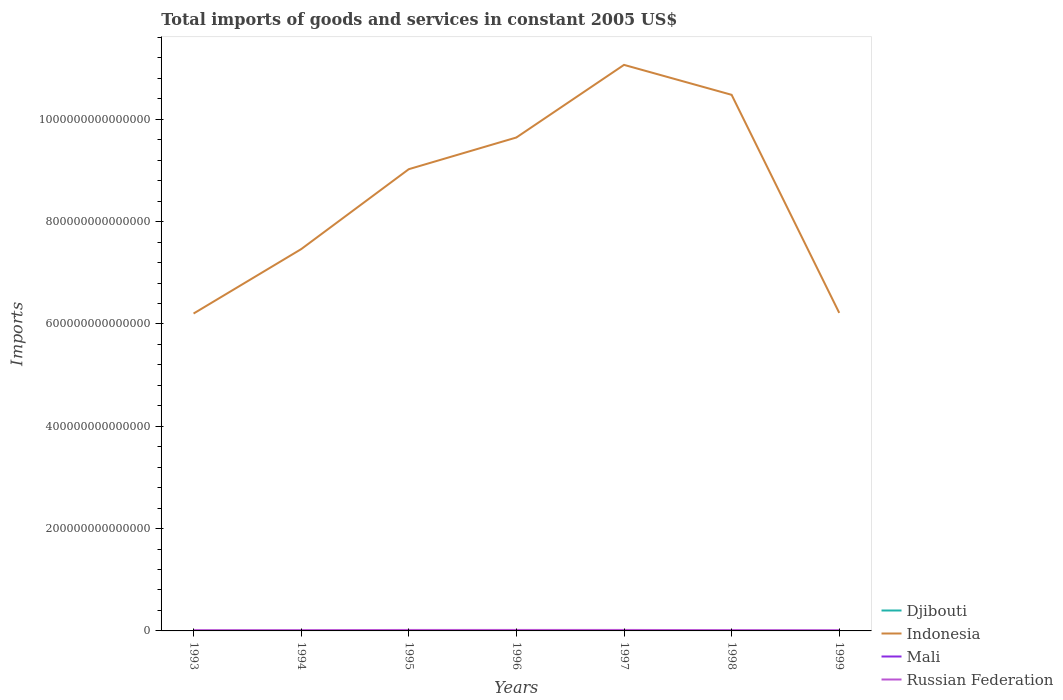How many different coloured lines are there?
Ensure brevity in your answer.  4. Does the line corresponding to Russian Federation intersect with the line corresponding to Djibouti?
Provide a succinct answer. No. Across all years, what is the maximum total imports of goods and services in Indonesia?
Ensure brevity in your answer.  6.20e+14. In which year was the total imports of goods and services in Djibouti maximum?
Offer a very short reply. 1999. What is the total total imports of goods and services in Djibouti in the graph?
Make the answer very short. 1.29e+1. What is the difference between the highest and the second highest total imports of goods and services in Djibouti?
Your answer should be compact. 1.38e+1. What is the difference between the highest and the lowest total imports of goods and services in Mali?
Provide a short and direct response. 3. Is the total imports of goods and services in Mali strictly greater than the total imports of goods and services in Djibouti over the years?
Offer a very short reply. No. How many lines are there?
Provide a succinct answer. 4. How many years are there in the graph?
Offer a terse response. 7. What is the difference between two consecutive major ticks on the Y-axis?
Provide a short and direct response. 2.00e+14. Are the values on the major ticks of Y-axis written in scientific E-notation?
Ensure brevity in your answer.  No. Does the graph contain any zero values?
Give a very brief answer. No. How many legend labels are there?
Provide a succinct answer. 4. How are the legend labels stacked?
Keep it short and to the point. Vertical. What is the title of the graph?
Make the answer very short. Total imports of goods and services in constant 2005 US$. What is the label or title of the Y-axis?
Offer a very short reply. Imports. What is the Imports of Djibouti in 1993?
Provide a short and direct response. 4.61e+1. What is the Imports of Indonesia in 1993?
Your answer should be very brief. 6.20e+14. What is the Imports in Mali in 1993?
Your answer should be compact. 2.15e+11. What is the Imports in Russian Federation in 1993?
Provide a short and direct response. 1.51e+12. What is the Imports in Djibouti in 1994?
Provide a short and direct response. 3.99e+1. What is the Imports of Indonesia in 1994?
Offer a very short reply. 7.46e+14. What is the Imports in Mali in 1994?
Make the answer very short. 1.93e+11. What is the Imports in Russian Federation in 1994?
Your response must be concise. 1.57e+12. What is the Imports in Djibouti in 1995?
Make the answer very short. 3.52e+1. What is the Imports in Indonesia in 1995?
Offer a terse response. 9.03e+14. What is the Imports of Mali in 1995?
Keep it short and to the point. 2.36e+11. What is the Imports in Russian Federation in 1995?
Ensure brevity in your answer.  1.90e+12. What is the Imports of Djibouti in 1996?
Offer a terse response. 3.32e+1. What is the Imports in Indonesia in 1996?
Your response must be concise. 9.65e+14. What is the Imports of Mali in 1996?
Offer a terse response. 2.27e+11. What is the Imports in Russian Federation in 1996?
Give a very brief answer. 1.93e+12. What is the Imports of Djibouti in 1997?
Keep it short and to the point. 3.29e+1. What is the Imports in Indonesia in 1997?
Ensure brevity in your answer.  1.11e+15. What is the Imports of Mali in 1997?
Provide a succinct answer. 2.42e+11. What is the Imports of Russian Federation in 1997?
Your response must be concise. 1.93e+12. What is the Imports in Djibouti in 1998?
Ensure brevity in your answer.  3.50e+1. What is the Imports of Indonesia in 1998?
Make the answer very short. 1.05e+15. What is the Imports of Mali in 1998?
Your answer should be very brief. 2.80e+11. What is the Imports of Russian Federation in 1998?
Your answer should be compact. 1.60e+12. What is the Imports in Djibouti in 1999?
Provide a succinct answer. 3.23e+1. What is the Imports of Indonesia in 1999?
Ensure brevity in your answer.  6.22e+14. What is the Imports of Mali in 1999?
Offer a terse response. 2.89e+11. What is the Imports in Russian Federation in 1999?
Make the answer very short. 1.33e+12. Across all years, what is the maximum Imports of Djibouti?
Ensure brevity in your answer.  4.61e+1. Across all years, what is the maximum Imports in Indonesia?
Keep it short and to the point. 1.11e+15. Across all years, what is the maximum Imports of Mali?
Offer a very short reply. 2.89e+11. Across all years, what is the maximum Imports in Russian Federation?
Offer a very short reply. 1.93e+12. Across all years, what is the minimum Imports of Djibouti?
Ensure brevity in your answer.  3.23e+1. Across all years, what is the minimum Imports in Indonesia?
Provide a short and direct response. 6.20e+14. Across all years, what is the minimum Imports of Mali?
Make the answer very short. 1.93e+11. Across all years, what is the minimum Imports in Russian Federation?
Make the answer very short. 1.33e+12. What is the total Imports in Djibouti in the graph?
Make the answer very short. 2.55e+11. What is the total Imports of Indonesia in the graph?
Provide a succinct answer. 6.01e+15. What is the total Imports in Mali in the graph?
Offer a terse response. 1.68e+12. What is the total Imports of Russian Federation in the graph?
Your answer should be very brief. 1.18e+13. What is the difference between the Imports in Djibouti in 1993 and that in 1994?
Offer a very short reply. 6.25e+09. What is the difference between the Imports of Indonesia in 1993 and that in 1994?
Offer a terse response. -1.26e+14. What is the difference between the Imports in Mali in 1993 and that in 1994?
Offer a very short reply. 2.21e+1. What is the difference between the Imports in Russian Federation in 1993 and that in 1994?
Offer a terse response. -6.35e+1. What is the difference between the Imports in Djibouti in 1993 and that in 1995?
Make the answer very short. 1.09e+1. What is the difference between the Imports of Indonesia in 1993 and that in 1995?
Offer a terse response. -2.82e+14. What is the difference between the Imports in Mali in 1993 and that in 1995?
Offer a very short reply. -2.08e+1. What is the difference between the Imports of Russian Federation in 1993 and that in 1995?
Keep it short and to the point. -3.96e+11. What is the difference between the Imports of Djibouti in 1993 and that in 1996?
Provide a short and direct response. 1.29e+1. What is the difference between the Imports of Indonesia in 1993 and that in 1996?
Your answer should be compact. -3.44e+14. What is the difference between the Imports of Mali in 1993 and that in 1996?
Your response must be concise. -1.21e+1. What is the difference between the Imports in Russian Federation in 1993 and that in 1996?
Keep it short and to the point. -4.20e+11. What is the difference between the Imports in Djibouti in 1993 and that in 1997?
Offer a very short reply. 1.32e+1. What is the difference between the Imports of Indonesia in 1993 and that in 1997?
Provide a short and direct response. -4.86e+14. What is the difference between the Imports of Mali in 1993 and that in 1997?
Make the answer very short. -2.70e+1. What is the difference between the Imports in Russian Federation in 1993 and that in 1997?
Your answer should be very brief. -4.28e+11. What is the difference between the Imports of Djibouti in 1993 and that in 1998?
Your response must be concise. 1.12e+1. What is the difference between the Imports in Indonesia in 1993 and that in 1998?
Your answer should be very brief. -4.28e+14. What is the difference between the Imports in Mali in 1993 and that in 1998?
Provide a succinct answer. -6.44e+1. What is the difference between the Imports of Russian Federation in 1993 and that in 1998?
Keep it short and to the point. -9.15e+1. What is the difference between the Imports in Djibouti in 1993 and that in 1999?
Give a very brief answer. 1.38e+1. What is the difference between the Imports of Indonesia in 1993 and that in 1999?
Ensure brevity in your answer.  -1.29e+12. What is the difference between the Imports in Mali in 1993 and that in 1999?
Your answer should be compact. -7.41e+1. What is the difference between the Imports of Russian Federation in 1993 and that in 1999?
Offer a very short reply. 1.80e+11. What is the difference between the Imports of Djibouti in 1994 and that in 1995?
Provide a succinct answer. 4.70e+09. What is the difference between the Imports of Indonesia in 1994 and that in 1995?
Provide a succinct answer. -1.56e+14. What is the difference between the Imports of Mali in 1994 and that in 1995?
Your answer should be compact. -4.29e+1. What is the difference between the Imports in Russian Federation in 1994 and that in 1995?
Provide a short and direct response. -3.32e+11. What is the difference between the Imports in Djibouti in 1994 and that in 1996?
Offer a terse response. 6.69e+09. What is the difference between the Imports of Indonesia in 1994 and that in 1996?
Provide a succinct answer. -2.18e+14. What is the difference between the Imports in Mali in 1994 and that in 1996?
Provide a short and direct response. -3.41e+1. What is the difference between the Imports in Russian Federation in 1994 and that in 1996?
Give a very brief answer. -3.57e+11. What is the difference between the Imports of Djibouti in 1994 and that in 1997?
Make the answer very short. 6.97e+09. What is the difference between the Imports in Indonesia in 1994 and that in 1997?
Provide a succinct answer. -3.60e+14. What is the difference between the Imports in Mali in 1994 and that in 1997?
Make the answer very short. -4.90e+1. What is the difference between the Imports in Russian Federation in 1994 and that in 1997?
Offer a very short reply. -3.65e+11. What is the difference between the Imports in Djibouti in 1994 and that in 1998?
Your answer should be very brief. 4.90e+09. What is the difference between the Imports of Indonesia in 1994 and that in 1998?
Your answer should be very brief. -3.02e+14. What is the difference between the Imports of Mali in 1994 and that in 1998?
Your answer should be very brief. -8.65e+1. What is the difference between the Imports in Russian Federation in 1994 and that in 1998?
Provide a short and direct response. -2.80e+1. What is the difference between the Imports in Djibouti in 1994 and that in 1999?
Make the answer very short. 7.54e+09. What is the difference between the Imports of Indonesia in 1994 and that in 1999?
Keep it short and to the point. 1.25e+14. What is the difference between the Imports of Mali in 1994 and that in 1999?
Ensure brevity in your answer.  -9.62e+1. What is the difference between the Imports in Russian Federation in 1994 and that in 1999?
Your answer should be very brief. 2.44e+11. What is the difference between the Imports of Djibouti in 1995 and that in 1996?
Ensure brevity in your answer.  2.00e+09. What is the difference between the Imports in Indonesia in 1995 and that in 1996?
Your response must be concise. -6.20e+13. What is the difference between the Imports of Mali in 1995 and that in 1996?
Offer a terse response. 8.77e+09. What is the difference between the Imports in Russian Federation in 1995 and that in 1996?
Make the answer very short. -2.47e+1. What is the difference between the Imports of Djibouti in 1995 and that in 1997?
Offer a very short reply. 2.28e+09. What is the difference between the Imports of Indonesia in 1995 and that in 1997?
Your answer should be compact. -2.04e+14. What is the difference between the Imports of Mali in 1995 and that in 1997?
Ensure brevity in your answer.  -6.14e+09. What is the difference between the Imports of Russian Federation in 1995 and that in 1997?
Offer a terse response. -3.24e+1. What is the difference between the Imports in Djibouti in 1995 and that in 1998?
Make the answer very short. 2.03e+08. What is the difference between the Imports of Indonesia in 1995 and that in 1998?
Offer a terse response. -1.45e+14. What is the difference between the Imports of Mali in 1995 and that in 1998?
Make the answer very short. -4.36e+1. What is the difference between the Imports of Russian Federation in 1995 and that in 1998?
Offer a terse response. 3.04e+11. What is the difference between the Imports in Djibouti in 1995 and that in 1999?
Make the answer very short. 2.85e+09. What is the difference between the Imports of Indonesia in 1995 and that in 1999?
Ensure brevity in your answer.  2.81e+14. What is the difference between the Imports in Mali in 1995 and that in 1999?
Provide a succinct answer. -5.32e+1. What is the difference between the Imports of Russian Federation in 1995 and that in 1999?
Keep it short and to the point. 5.76e+11. What is the difference between the Imports in Djibouti in 1996 and that in 1997?
Give a very brief answer. 2.83e+08. What is the difference between the Imports in Indonesia in 1996 and that in 1997?
Give a very brief answer. -1.42e+14. What is the difference between the Imports of Mali in 1996 and that in 1997?
Give a very brief answer. -1.49e+1. What is the difference between the Imports of Russian Federation in 1996 and that in 1997?
Make the answer very short. -7.71e+09. What is the difference between the Imports of Djibouti in 1996 and that in 1998?
Your answer should be very brief. -1.79e+09. What is the difference between the Imports of Indonesia in 1996 and that in 1998?
Give a very brief answer. -8.34e+13. What is the difference between the Imports of Mali in 1996 and that in 1998?
Keep it short and to the point. -5.24e+1. What is the difference between the Imports of Russian Federation in 1996 and that in 1998?
Make the answer very short. 3.29e+11. What is the difference between the Imports in Djibouti in 1996 and that in 1999?
Provide a succinct answer. 8.53e+08. What is the difference between the Imports in Indonesia in 1996 and that in 1999?
Provide a short and direct response. 3.43e+14. What is the difference between the Imports of Mali in 1996 and that in 1999?
Give a very brief answer. -6.20e+1. What is the difference between the Imports of Russian Federation in 1996 and that in 1999?
Your answer should be compact. 6.00e+11. What is the difference between the Imports in Djibouti in 1997 and that in 1998?
Offer a terse response. -2.08e+09. What is the difference between the Imports in Indonesia in 1997 and that in 1998?
Your answer should be very brief. 5.85e+13. What is the difference between the Imports of Mali in 1997 and that in 1998?
Provide a short and direct response. -3.74e+1. What is the difference between the Imports of Russian Federation in 1997 and that in 1998?
Provide a succinct answer. 3.37e+11. What is the difference between the Imports of Djibouti in 1997 and that in 1999?
Offer a very short reply. 5.70e+08. What is the difference between the Imports in Indonesia in 1997 and that in 1999?
Your response must be concise. 4.85e+14. What is the difference between the Imports in Mali in 1997 and that in 1999?
Offer a terse response. -4.71e+1. What is the difference between the Imports in Russian Federation in 1997 and that in 1999?
Offer a very short reply. 6.08e+11. What is the difference between the Imports in Djibouti in 1998 and that in 1999?
Your response must be concise. 2.65e+09. What is the difference between the Imports in Indonesia in 1998 and that in 1999?
Your answer should be very brief. 4.26e+14. What is the difference between the Imports of Mali in 1998 and that in 1999?
Give a very brief answer. -9.66e+09. What is the difference between the Imports of Russian Federation in 1998 and that in 1999?
Offer a terse response. 2.72e+11. What is the difference between the Imports in Djibouti in 1993 and the Imports in Indonesia in 1994?
Your answer should be very brief. -7.46e+14. What is the difference between the Imports in Djibouti in 1993 and the Imports in Mali in 1994?
Offer a terse response. -1.47e+11. What is the difference between the Imports of Djibouti in 1993 and the Imports of Russian Federation in 1994?
Offer a terse response. -1.52e+12. What is the difference between the Imports in Indonesia in 1993 and the Imports in Mali in 1994?
Keep it short and to the point. 6.20e+14. What is the difference between the Imports in Indonesia in 1993 and the Imports in Russian Federation in 1994?
Your response must be concise. 6.19e+14. What is the difference between the Imports of Mali in 1993 and the Imports of Russian Federation in 1994?
Your answer should be compact. -1.35e+12. What is the difference between the Imports in Djibouti in 1993 and the Imports in Indonesia in 1995?
Provide a succinct answer. -9.03e+14. What is the difference between the Imports of Djibouti in 1993 and the Imports of Mali in 1995?
Offer a terse response. -1.90e+11. What is the difference between the Imports in Djibouti in 1993 and the Imports in Russian Federation in 1995?
Give a very brief answer. -1.86e+12. What is the difference between the Imports of Indonesia in 1993 and the Imports of Mali in 1995?
Offer a terse response. 6.20e+14. What is the difference between the Imports of Indonesia in 1993 and the Imports of Russian Federation in 1995?
Give a very brief answer. 6.19e+14. What is the difference between the Imports in Mali in 1993 and the Imports in Russian Federation in 1995?
Provide a short and direct response. -1.69e+12. What is the difference between the Imports in Djibouti in 1993 and the Imports in Indonesia in 1996?
Your response must be concise. -9.65e+14. What is the difference between the Imports in Djibouti in 1993 and the Imports in Mali in 1996?
Offer a terse response. -1.81e+11. What is the difference between the Imports of Djibouti in 1993 and the Imports of Russian Federation in 1996?
Offer a very short reply. -1.88e+12. What is the difference between the Imports of Indonesia in 1993 and the Imports of Mali in 1996?
Make the answer very short. 6.20e+14. What is the difference between the Imports of Indonesia in 1993 and the Imports of Russian Federation in 1996?
Keep it short and to the point. 6.18e+14. What is the difference between the Imports of Mali in 1993 and the Imports of Russian Federation in 1996?
Give a very brief answer. -1.71e+12. What is the difference between the Imports of Djibouti in 1993 and the Imports of Indonesia in 1997?
Your answer should be compact. -1.11e+15. What is the difference between the Imports in Djibouti in 1993 and the Imports in Mali in 1997?
Ensure brevity in your answer.  -1.96e+11. What is the difference between the Imports in Djibouti in 1993 and the Imports in Russian Federation in 1997?
Provide a succinct answer. -1.89e+12. What is the difference between the Imports in Indonesia in 1993 and the Imports in Mali in 1997?
Keep it short and to the point. 6.20e+14. What is the difference between the Imports of Indonesia in 1993 and the Imports of Russian Federation in 1997?
Your answer should be very brief. 6.18e+14. What is the difference between the Imports in Mali in 1993 and the Imports in Russian Federation in 1997?
Provide a short and direct response. -1.72e+12. What is the difference between the Imports in Djibouti in 1993 and the Imports in Indonesia in 1998?
Offer a terse response. -1.05e+15. What is the difference between the Imports in Djibouti in 1993 and the Imports in Mali in 1998?
Keep it short and to the point. -2.34e+11. What is the difference between the Imports in Djibouti in 1993 and the Imports in Russian Federation in 1998?
Your answer should be compact. -1.55e+12. What is the difference between the Imports in Indonesia in 1993 and the Imports in Mali in 1998?
Make the answer very short. 6.20e+14. What is the difference between the Imports in Indonesia in 1993 and the Imports in Russian Federation in 1998?
Ensure brevity in your answer.  6.19e+14. What is the difference between the Imports of Mali in 1993 and the Imports of Russian Federation in 1998?
Provide a short and direct response. -1.38e+12. What is the difference between the Imports of Djibouti in 1993 and the Imports of Indonesia in 1999?
Provide a succinct answer. -6.22e+14. What is the difference between the Imports in Djibouti in 1993 and the Imports in Mali in 1999?
Provide a short and direct response. -2.43e+11. What is the difference between the Imports in Djibouti in 1993 and the Imports in Russian Federation in 1999?
Give a very brief answer. -1.28e+12. What is the difference between the Imports in Indonesia in 1993 and the Imports in Mali in 1999?
Your answer should be compact. 6.20e+14. What is the difference between the Imports of Indonesia in 1993 and the Imports of Russian Federation in 1999?
Provide a short and direct response. 6.19e+14. What is the difference between the Imports in Mali in 1993 and the Imports in Russian Federation in 1999?
Your answer should be compact. -1.11e+12. What is the difference between the Imports of Djibouti in 1994 and the Imports of Indonesia in 1995?
Give a very brief answer. -9.03e+14. What is the difference between the Imports in Djibouti in 1994 and the Imports in Mali in 1995?
Your answer should be compact. -1.96e+11. What is the difference between the Imports in Djibouti in 1994 and the Imports in Russian Federation in 1995?
Provide a short and direct response. -1.86e+12. What is the difference between the Imports of Indonesia in 1994 and the Imports of Mali in 1995?
Provide a short and direct response. 7.46e+14. What is the difference between the Imports in Indonesia in 1994 and the Imports in Russian Federation in 1995?
Offer a terse response. 7.44e+14. What is the difference between the Imports in Mali in 1994 and the Imports in Russian Federation in 1995?
Provide a succinct answer. -1.71e+12. What is the difference between the Imports of Djibouti in 1994 and the Imports of Indonesia in 1996?
Make the answer very short. -9.65e+14. What is the difference between the Imports in Djibouti in 1994 and the Imports in Mali in 1996?
Your answer should be compact. -1.88e+11. What is the difference between the Imports of Djibouti in 1994 and the Imports of Russian Federation in 1996?
Your response must be concise. -1.89e+12. What is the difference between the Imports of Indonesia in 1994 and the Imports of Mali in 1996?
Provide a succinct answer. 7.46e+14. What is the difference between the Imports of Indonesia in 1994 and the Imports of Russian Federation in 1996?
Offer a very short reply. 7.44e+14. What is the difference between the Imports in Mali in 1994 and the Imports in Russian Federation in 1996?
Provide a short and direct response. -1.73e+12. What is the difference between the Imports of Djibouti in 1994 and the Imports of Indonesia in 1997?
Your answer should be very brief. -1.11e+15. What is the difference between the Imports in Djibouti in 1994 and the Imports in Mali in 1997?
Your response must be concise. -2.02e+11. What is the difference between the Imports of Djibouti in 1994 and the Imports of Russian Federation in 1997?
Ensure brevity in your answer.  -1.89e+12. What is the difference between the Imports in Indonesia in 1994 and the Imports in Mali in 1997?
Ensure brevity in your answer.  7.46e+14. What is the difference between the Imports in Indonesia in 1994 and the Imports in Russian Federation in 1997?
Offer a very short reply. 7.44e+14. What is the difference between the Imports of Mali in 1994 and the Imports of Russian Federation in 1997?
Provide a succinct answer. -1.74e+12. What is the difference between the Imports of Djibouti in 1994 and the Imports of Indonesia in 1998?
Keep it short and to the point. -1.05e+15. What is the difference between the Imports in Djibouti in 1994 and the Imports in Mali in 1998?
Provide a short and direct response. -2.40e+11. What is the difference between the Imports in Djibouti in 1994 and the Imports in Russian Federation in 1998?
Your answer should be very brief. -1.56e+12. What is the difference between the Imports in Indonesia in 1994 and the Imports in Mali in 1998?
Your answer should be very brief. 7.46e+14. What is the difference between the Imports in Indonesia in 1994 and the Imports in Russian Federation in 1998?
Ensure brevity in your answer.  7.45e+14. What is the difference between the Imports in Mali in 1994 and the Imports in Russian Federation in 1998?
Offer a terse response. -1.40e+12. What is the difference between the Imports of Djibouti in 1994 and the Imports of Indonesia in 1999?
Offer a very short reply. -6.22e+14. What is the difference between the Imports in Djibouti in 1994 and the Imports in Mali in 1999?
Ensure brevity in your answer.  -2.50e+11. What is the difference between the Imports in Djibouti in 1994 and the Imports in Russian Federation in 1999?
Keep it short and to the point. -1.29e+12. What is the difference between the Imports in Indonesia in 1994 and the Imports in Mali in 1999?
Make the answer very short. 7.46e+14. What is the difference between the Imports of Indonesia in 1994 and the Imports of Russian Federation in 1999?
Give a very brief answer. 7.45e+14. What is the difference between the Imports of Mali in 1994 and the Imports of Russian Federation in 1999?
Give a very brief answer. -1.13e+12. What is the difference between the Imports of Djibouti in 1995 and the Imports of Indonesia in 1996?
Your answer should be compact. -9.65e+14. What is the difference between the Imports in Djibouti in 1995 and the Imports in Mali in 1996?
Give a very brief answer. -1.92e+11. What is the difference between the Imports of Djibouti in 1995 and the Imports of Russian Federation in 1996?
Ensure brevity in your answer.  -1.89e+12. What is the difference between the Imports of Indonesia in 1995 and the Imports of Mali in 1996?
Your answer should be compact. 9.02e+14. What is the difference between the Imports in Indonesia in 1995 and the Imports in Russian Federation in 1996?
Your response must be concise. 9.01e+14. What is the difference between the Imports in Mali in 1995 and the Imports in Russian Federation in 1996?
Offer a very short reply. -1.69e+12. What is the difference between the Imports of Djibouti in 1995 and the Imports of Indonesia in 1997?
Make the answer very short. -1.11e+15. What is the difference between the Imports in Djibouti in 1995 and the Imports in Mali in 1997?
Offer a terse response. -2.07e+11. What is the difference between the Imports of Djibouti in 1995 and the Imports of Russian Federation in 1997?
Provide a short and direct response. -1.90e+12. What is the difference between the Imports in Indonesia in 1995 and the Imports in Mali in 1997?
Your response must be concise. 9.02e+14. What is the difference between the Imports of Indonesia in 1995 and the Imports of Russian Federation in 1997?
Your response must be concise. 9.01e+14. What is the difference between the Imports of Mali in 1995 and the Imports of Russian Federation in 1997?
Give a very brief answer. -1.70e+12. What is the difference between the Imports of Djibouti in 1995 and the Imports of Indonesia in 1998?
Give a very brief answer. -1.05e+15. What is the difference between the Imports in Djibouti in 1995 and the Imports in Mali in 1998?
Keep it short and to the point. -2.45e+11. What is the difference between the Imports in Djibouti in 1995 and the Imports in Russian Federation in 1998?
Offer a very short reply. -1.56e+12. What is the difference between the Imports of Indonesia in 1995 and the Imports of Mali in 1998?
Your response must be concise. 9.02e+14. What is the difference between the Imports in Indonesia in 1995 and the Imports in Russian Federation in 1998?
Offer a terse response. 9.01e+14. What is the difference between the Imports in Mali in 1995 and the Imports in Russian Federation in 1998?
Offer a very short reply. -1.36e+12. What is the difference between the Imports in Djibouti in 1995 and the Imports in Indonesia in 1999?
Your answer should be compact. -6.22e+14. What is the difference between the Imports of Djibouti in 1995 and the Imports of Mali in 1999?
Provide a succinct answer. -2.54e+11. What is the difference between the Imports in Djibouti in 1995 and the Imports in Russian Federation in 1999?
Your answer should be compact. -1.29e+12. What is the difference between the Imports in Indonesia in 1995 and the Imports in Mali in 1999?
Your response must be concise. 9.02e+14. What is the difference between the Imports of Indonesia in 1995 and the Imports of Russian Federation in 1999?
Your answer should be compact. 9.01e+14. What is the difference between the Imports in Mali in 1995 and the Imports in Russian Federation in 1999?
Ensure brevity in your answer.  -1.09e+12. What is the difference between the Imports of Djibouti in 1996 and the Imports of Indonesia in 1997?
Offer a terse response. -1.11e+15. What is the difference between the Imports in Djibouti in 1996 and the Imports in Mali in 1997?
Your answer should be very brief. -2.09e+11. What is the difference between the Imports in Djibouti in 1996 and the Imports in Russian Federation in 1997?
Provide a succinct answer. -1.90e+12. What is the difference between the Imports of Indonesia in 1996 and the Imports of Mali in 1997?
Provide a short and direct response. 9.64e+14. What is the difference between the Imports of Indonesia in 1996 and the Imports of Russian Federation in 1997?
Offer a very short reply. 9.63e+14. What is the difference between the Imports of Mali in 1996 and the Imports of Russian Federation in 1997?
Make the answer very short. -1.71e+12. What is the difference between the Imports of Djibouti in 1996 and the Imports of Indonesia in 1998?
Your answer should be very brief. -1.05e+15. What is the difference between the Imports of Djibouti in 1996 and the Imports of Mali in 1998?
Make the answer very short. -2.47e+11. What is the difference between the Imports in Djibouti in 1996 and the Imports in Russian Federation in 1998?
Make the answer very short. -1.56e+12. What is the difference between the Imports of Indonesia in 1996 and the Imports of Mali in 1998?
Keep it short and to the point. 9.64e+14. What is the difference between the Imports in Indonesia in 1996 and the Imports in Russian Federation in 1998?
Ensure brevity in your answer.  9.63e+14. What is the difference between the Imports in Mali in 1996 and the Imports in Russian Federation in 1998?
Provide a short and direct response. -1.37e+12. What is the difference between the Imports of Djibouti in 1996 and the Imports of Indonesia in 1999?
Make the answer very short. -6.22e+14. What is the difference between the Imports of Djibouti in 1996 and the Imports of Mali in 1999?
Provide a short and direct response. -2.56e+11. What is the difference between the Imports of Djibouti in 1996 and the Imports of Russian Federation in 1999?
Your response must be concise. -1.29e+12. What is the difference between the Imports of Indonesia in 1996 and the Imports of Mali in 1999?
Keep it short and to the point. 9.64e+14. What is the difference between the Imports of Indonesia in 1996 and the Imports of Russian Federation in 1999?
Offer a very short reply. 9.63e+14. What is the difference between the Imports in Mali in 1996 and the Imports in Russian Federation in 1999?
Your answer should be compact. -1.10e+12. What is the difference between the Imports in Djibouti in 1997 and the Imports in Indonesia in 1998?
Keep it short and to the point. -1.05e+15. What is the difference between the Imports in Djibouti in 1997 and the Imports in Mali in 1998?
Ensure brevity in your answer.  -2.47e+11. What is the difference between the Imports of Djibouti in 1997 and the Imports of Russian Federation in 1998?
Ensure brevity in your answer.  -1.56e+12. What is the difference between the Imports in Indonesia in 1997 and the Imports in Mali in 1998?
Provide a short and direct response. 1.11e+15. What is the difference between the Imports in Indonesia in 1997 and the Imports in Russian Federation in 1998?
Provide a succinct answer. 1.10e+15. What is the difference between the Imports of Mali in 1997 and the Imports of Russian Federation in 1998?
Offer a terse response. -1.36e+12. What is the difference between the Imports in Djibouti in 1997 and the Imports in Indonesia in 1999?
Your answer should be very brief. -6.22e+14. What is the difference between the Imports of Djibouti in 1997 and the Imports of Mali in 1999?
Offer a very short reply. -2.57e+11. What is the difference between the Imports in Djibouti in 1997 and the Imports in Russian Federation in 1999?
Ensure brevity in your answer.  -1.29e+12. What is the difference between the Imports in Indonesia in 1997 and the Imports in Mali in 1999?
Your answer should be compact. 1.11e+15. What is the difference between the Imports in Indonesia in 1997 and the Imports in Russian Federation in 1999?
Offer a very short reply. 1.11e+15. What is the difference between the Imports in Mali in 1997 and the Imports in Russian Federation in 1999?
Ensure brevity in your answer.  -1.08e+12. What is the difference between the Imports of Djibouti in 1998 and the Imports of Indonesia in 1999?
Ensure brevity in your answer.  -6.22e+14. What is the difference between the Imports of Djibouti in 1998 and the Imports of Mali in 1999?
Make the answer very short. -2.54e+11. What is the difference between the Imports of Djibouti in 1998 and the Imports of Russian Federation in 1999?
Your response must be concise. -1.29e+12. What is the difference between the Imports in Indonesia in 1998 and the Imports in Mali in 1999?
Keep it short and to the point. 1.05e+15. What is the difference between the Imports in Indonesia in 1998 and the Imports in Russian Federation in 1999?
Keep it short and to the point. 1.05e+15. What is the difference between the Imports of Mali in 1998 and the Imports of Russian Federation in 1999?
Your response must be concise. -1.05e+12. What is the average Imports of Djibouti per year?
Ensure brevity in your answer.  3.64e+1. What is the average Imports in Indonesia per year?
Offer a very short reply. 8.59e+14. What is the average Imports of Mali per year?
Your answer should be compact. 2.41e+11. What is the average Imports of Russian Federation per year?
Your answer should be compact. 1.68e+12. In the year 1993, what is the difference between the Imports in Djibouti and Imports in Indonesia?
Your answer should be very brief. -6.20e+14. In the year 1993, what is the difference between the Imports in Djibouti and Imports in Mali?
Provide a short and direct response. -1.69e+11. In the year 1993, what is the difference between the Imports in Djibouti and Imports in Russian Federation?
Give a very brief answer. -1.46e+12. In the year 1993, what is the difference between the Imports of Indonesia and Imports of Mali?
Offer a terse response. 6.20e+14. In the year 1993, what is the difference between the Imports of Indonesia and Imports of Russian Federation?
Your response must be concise. 6.19e+14. In the year 1993, what is the difference between the Imports of Mali and Imports of Russian Federation?
Keep it short and to the point. -1.29e+12. In the year 1994, what is the difference between the Imports in Djibouti and Imports in Indonesia?
Ensure brevity in your answer.  -7.46e+14. In the year 1994, what is the difference between the Imports of Djibouti and Imports of Mali?
Offer a very short reply. -1.53e+11. In the year 1994, what is the difference between the Imports of Djibouti and Imports of Russian Federation?
Offer a very short reply. -1.53e+12. In the year 1994, what is the difference between the Imports in Indonesia and Imports in Mali?
Offer a terse response. 7.46e+14. In the year 1994, what is the difference between the Imports of Indonesia and Imports of Russian Federation?
Offer a terse response. 7.45e+14. In the year 1994, what is the difference between the Imports in Mali and Imports in Russian Federation?
Give a very brief answer. -1.38e+12. In the year 1995, what is the difference between the Imports of Djibouti and Imports of Indonesia?
Offer a very short reply. -9.03e+14. In the year 1995, what is the difference between the Imports of Djibouti and Imports of Mali?
Give a very brief answer. -2.01e+11. In the year 1995, what is the difference between the Imports in Djibouti and Imports in Russian Federation?
Provide a succinct answer. -1.87e+12. In the year 1995, what is the difference between the Imports of Indonesia and Imports of Mali?
Provide a succinct answer. 9.02e+14. In the year 1995, what is the difference between the Imports of Indonesia and Imports of Russian Federation?
Offer a terse response. 9.01e+14. In the year 1995, what is the difference between the Imports of Mali and Imports of Russian Federation?
Keep it short and to the point. -1.67e+12. In the year 1996, what is the difference between the Imports of Djibouti and Imports of Indonesia?
Your answer should be compact. -9.65e+14. In the year 1996, what is the difference between the Imports of Djibouti and Imports of Mali?
Provide a succinct answer. -1.94e+11. In the year 1996, what is the difference between the Imports in Djibouti and Imports in Russian Federation?
Provide a succinct answer. -1.89e+12. In the year 1996, what is the difference between the Imports of Indonesia and Imports of Mali?
Your answer should be compact. 9.64e+14. In the year 1996, what is the difference between the Imports in Indonesia and Imports in Russian Federation?
Provide a short and direct response. 9.63e+14. In the year 1996, what is the difference between the Imports in Mali and Imports in Russian Federation?
Your answer should be very brief. -1.70e+12. In the year 1997, what is the difference between the Imports of Djibouti and Imports of Indonesia?
Ensure brevity in your answer.  -1.11e+15. In the year 1997, what is the difference between the Imports of Djibouti and Imports of Mali?
Your answer should be compact. -2.09e+11. In the year 1997, what is the difference between the Imports in Djibouti and Imports in Russian Federation?
Your response must be concise. -1.90e+12. In the year 1997, what is the difference between the Imports of Indonesia and Imports of Mali?
Give a very brief answer. 1.11e+15. In the year 1997, what is the difference between the Imports in Indonesia and Imports in Russian Federation?
Give a very brief answer. 1.10e+15. In the year 1997, what is the difference between the Imports in Mali and Imports in Russian Federation?
Keep it short and to the point. -1.69e+12. In the year 1998, what is the difference between the Imports in Djibouti and Imports in Indonesia?
Provide a short and direct response. -1.05e+15. In the year 1998, what is the difference between the Imports of Djibouti and Imports of Mali?
Keep it short and to the point. -2.45e+11. In the year 1998, what is the difference between the Imports of Djibouti and Imports of Russian Federation?
Give a very brief answer. -1.56e+12. In the year 1998, what is the difference between the Imports in Indonesia and Imports in Mali?
Offer a terse response. 1.05e+15. In the year 1998, what is the difference between the Imports in Indonesia and Imports in Russian Federation?
Provide a succinct answer. 1.05e+15. In the year 1998, what is the difference between the Imports of Mali and Imports of Russian Federation?
Ensure brevity in your answer.  -1.32e+12. In the year 1999, what is the difference between the Imports in Djibouti and Imports in Indonesia?
Provide a succinct answer. -6.22e+14. In the year 1999, what is the difference between the Imports in Djibouti and Imports in Mali?
Provide a short and direct response. -2.57e+11. In the year 1999, what is the difference between the Imports in Djibouti and Imports in Russian Federation?
Provide a short and direct response. -1.29e+12. In the year 1999, what is the difference between the Imports in Indonesia and Imports in Mali?
Ensure brevity in your answer.  6.21e+14. In the year 1999, what is the difference between the Imports of Indonesia and Imports of Russian Federation?
Offer a terse response. 6.20e+14. In the year 1999, what is the difference between the Imports of Mali and Imports of Russian Federation?
Ensure brevity in your answer.  -1.04e+12. What is the ratio of the Imports of Djibouti in 1993 to that in 1994?
Provide a short and direct response. 1.16. What is the ratio of the Imports in Indonesia in 1993 to that in 1994?
Your answer should be compact. 0.83. What is the ratio of the Imports of Mali in 1993 to that in 1994?
Offer a very short reply. 1.11. What is the ratio of the Imports in Russian Federation in 1993 to that in 1994?
Offer a very short reply. 0.96. What is the ratio of the Imports in Djibouti in 1993 to that in 1995?
Your answer should be very brief. 1.31. What is the ratio of the Imports of Indonesia in 1993 to that in 1995?
Offer a very short reply. 0.69. What is the ratio of the Imports in Mali in 1993 to that in 1995?
Offer a terse response. 0.91. What is the ratio of the Imports in Russian Federation in 1993 to that in 1995?
Provide a short and direct response. 0.79. What is the ratio of the Imports in Djibouti in 1993 to that in 1996?
Your response must be concise. 1.39. What is the ratio of the Imports of Indonesia in 1993 to that in 1996?
Give a very brief answer. 0.64. What is the ratio of the Imports in Mali in 1993 to that in 1996?
Ensure brevity in your answer.  0.95. What is the ratio of the Imports in Russian Federation in 1993 to that in 1996?
Offer a very short reply. 0.78. What is the ratio of the Imports in Djibouti in 1993 to that in 1997?
Give a very brief answer. 1.4. What is the ratio of the Imports in Indonesia in 1993 to that in 1997?
Offer a very short reply. 0.56. What is the ratio of the Imports of Mali in 1993 to that in 1997?
Your response must be concise. 0.89. What is the ratio of the Imports of Russian Federation in 1993 to that in 1997?
Your answer should be very brief. 0.78. What is the ratio of the Imports of Djibouti in 1993 to that in 1998?
Make the answer very short. 1.32. What is the ratio of the Imports in Indonesia in 1993 to that in 1998?
Offer a very short reply. 0.59. What is the ratio of the Imports in Mali in 1993 to that in 1998?
Offer a very short reply. 0.77. What is the ratio of the Imports of Russian Federation in 1993 to that in 1998?
Ensure brevity in your answer.  0.94. What is the ratio of the Imports in Djibouti in 1993 to that in 1999?
Provide a succinct answer. 1.43. What is the ratio of the Imports of Mali in 1993 to that in 1999?
Give a very brief answer. 0.74. What is the ratio of the Imports in Russian Federation in 1993 to that in 1999?
Keep it short and to the point. 1.14. What is the ratio of the Imports in Djibouti in 1994 to that in 1995?
Offer a terse response. 1.13. What is the ratio of the Imports of Indonesia in 1994 to that in 1995?
Make the answer very short. 0.83. What is the ratio of the Imports of Mali in 1994 to that in 1995?
Give a very brief answer. 0.82. What is the ratio of the Imports of Russian Federation in 1994 to that in 1995?
Offer a terse response. 0.83. What is the ratio of the Imports of Djibouti in 1994 to that in 1996?
Give a very brief answer. 1.2. What is the ratio of the Imports of Indonesia in 1994 to that in 1996?
Provide a short and direct response. 0.77. What is the ratio of the Imports of Mali in 1994 to that in 1996?
Your answer should be compact. 0.85. What is the ratio of the Imports of Russian Federation in 1994 to that in 1996?
Give a very brief answer. 0.81. What is the ratio of the Imports of Djibouti in 1994 to that in 1997?
Your answer should be compact. 1.21. What is the ratio of the Imports of Indonesia in 1994 to that in 1997?
Provide a succinct answer. 0.67. What is the ratio of the Imports in Mali in 1994 to that in 1997?
Offer a very short reply. 0.8. What is the ratio of the Imports in Russian Federation in 1994 to that in 1997?
Offer a very short reply. 0.81. What is the ratio of the Imports of Djibouti in 1994 to that in 1998?
Provide a succinct answer. 1.14. What is the ratio of the Imports in Indonesia in 1994 to that in 1998?
Your answer should be compact. 0.71. What is the ratio of the Imports of Mali in 1994 to that in 1998?
Ensure brevity in your answer.  0.69. What is the ratio of the Imports in Russian Federation in 1994 to that in 1998?
Make the answer very short. 0.98. What is the ratio of the Imports of Djibouti in 1994 to that in 1999?
Your response must be concise. 1.23. What is the ratio of the Imports in Indonesia in 1994 to that in 1999?
Your answer should be very brief. 1.2. What is the ratio of the Imports of Mali in 1994 to that in 1999?
Ensure brevity in your answer.  0.67. What is the ratio of the Imports in Russian Federation in 1994 to that in 1999?
Offer a terse response. 1.18. What is the ratio of the Imports in Djibouti in 1995 to that in 1996?
Provide a succinct answer. 1.06. What is the ratio of the Imports in Indonesia in 1995 to that in 1996?
Keep it short and to the point. 0.94. What is the ratio of the Imports of Mali in 1995 to that in 1996?
Offer a terse response. 1.04. What is the ratio of the Imports in Russian Federation in 1995 to that in 1996?
Your answer should be very brief. 0.99. What is the ratio of the Imports in Djibouti in 1995 to that in 1997?
Your answer should be compact. 1.07. What is the ratio of the Imports of Indonesia in 1995 to that in 1997?
Ensure brevity in your answer.  0.82. What is the ratio of the Imports of Mali in 1995 to that in 1997?
Keep it short and to the point. 0.97. What is the ratio of the Imports in Russian Federation in 1995 to that in 1997?
Offer a terse response. 0.98. What is the ratio of the Imports in Indonesia in 1995 to that in 1998?
Your answer should be very brief. 0.86. What is the ratio of the Imports in Mali in 1995 to that in 1998?
Offer a terse response. 0.84. What is the ratio of the Imports in Russian Federation in 1995 to that in 1998?
Provide a succinct answer. 1.19. What is the ratio of the Imports of Djibouti in 1995 to that in 1999?
Your response must be concise. 1.09. What is the ratio of the Imports of Indonesia in 1995 to that in 1999?
Make the answer very short. 1.45. What is the ratio of the Imports of Mali in 1995 to that in 1999?
Your response must be concise. 0.82. What is the ratio of the Imports in Russian Federation in 1995 to that in 1999?
Your answer should be compact. 1.43. What is the ratio of the Imports in Djibouti in 1996 to that in 1997?
Offer a terse response. 1.01. What is the ratio of the Imports of Indonesia in 1996 to that in 1997?
Keep it short and to the point. 0.87. What is the ratio of the Imports in Mali in 1996 to that in 1997?
Ensure brevity in your answer.  0.94. What is the ratio of the Imports of Djibouti in 1996 to that in 1998?
Make the answer very short. 0.95. What is the ratio of the Imports of Indonesia in 1996 to that in 1998?
Provide a succinct answer. 0.92. What is the ratio of the Imports of Mali in 1996 to that in 1998?
Make the answer very short. 0.81. What is the ratio of the Imports in Russian Federation in 1996 to that in 1998?
Provide a short and direct response. 1.21. What is the ratio of the Imports of Djibouti in 1996 to that in 1999?
Offer a very short reply. 1.03. What is the ratio of the Imports of Indonesia in 1996 to that in 1999?
Your answer should be very brief. 1.55. What is the ratio of the Imports of Mali in 1996 to that in 1999?
Keep it short and to the point. 0.79. What is the ratio of the Imports in Russian Federation in 1996 to that in 1999?
Keep it short and to the point. 1.45. What is the ratio of the Imports in Djibouti in 1997 to that in 1998?
Your answer should be compact. 0.94. What is the ratio of the Imports in Indonesia in 1997 to that in 1998?
Provide a succinct answer. 1.06. What is the ratio of the Imports in Mali in 1997 to that in 1998?
Your answer should be very brief. 0.87. What is the ratio of the Imports in Russian Federation in 1997 to that in 1998?
Keep it short and to the point. 1.21. What is the ratio of the Imports in Djibouti in 1997 to that in 1999?
Offer a very short reply. 1.02. What is the ratio of the Imports in Indonesia in 1997 to that in 1999?
Keep it short and to the point. 1.78. What is the ratio of the Imports of Mali in 1997 to that in 1999?
Your answer should be very brief. 0.84. What is the ratio of the Imports of Russian Federation in 1997 to that in 1999?
Provide a succinct answer. 1.46. What is the ratio of the Imports in Djibouti in 1998 to that in 1999?
Ensure brevity in your answer.  1.08. What is the ratio of the Imports in Indonesia in 1998 to that in 1999?
Offer a terse response. 1.69. What is the ratio of the Imports of Mali in 1998 to that in 1999?
Your response must be concise. 0.97. What is the ratio of the Imports of Russian Federation in 1998 to that in 1999?
Keep it short and to the point. 1.2. What is the difference between the highest and the second highest Imports in Djibouti?
Make the answer very short. 6.25e+09. What is the difference between the highest and the second highest Imports of Indonesia?
Provide a short and direct response. 5.85e+13. What is the difference between the highest and the second highest Imports of Mali?
Your response must be concise. 9.66e+09. What is the difference between the highest and the second highest Imports in Russian Federation?
Your answer should be compact. 7.71e+09. What is the difference between the highest and the lowest Imports in Djibouti?
Your answer should be compact. 1.38e+1. What is the difference between the highest and the lowest Imports of Indonesia?
Give a very brief answer. 4.86e+14. What is the difference between the highest and the lowest Imports in Mali?
Your answer should be compact. 9.62e+1. What is the difference between the highest and the lowest Imports in Russian Federation?
Offer a very short reply. 6.08e+11. 